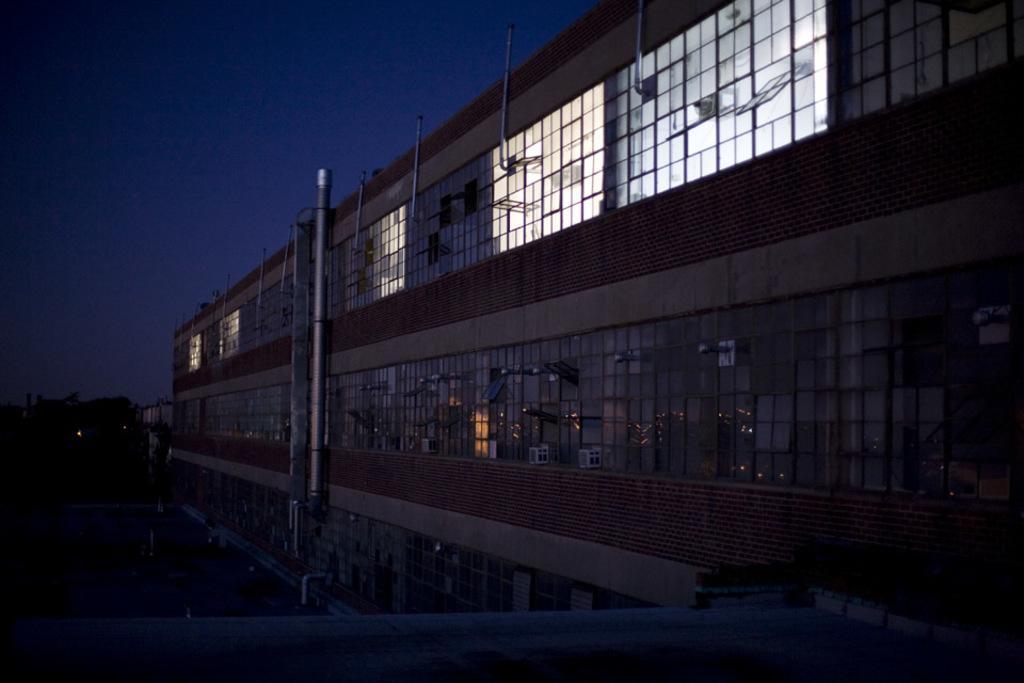Describe this image in one or two sentences. In the center of the picture there is a building with glass windows, at the top there are lights on in the building. On the left it is dark. At the top it is sky. In the middle of the picture there are pipe like objects. 